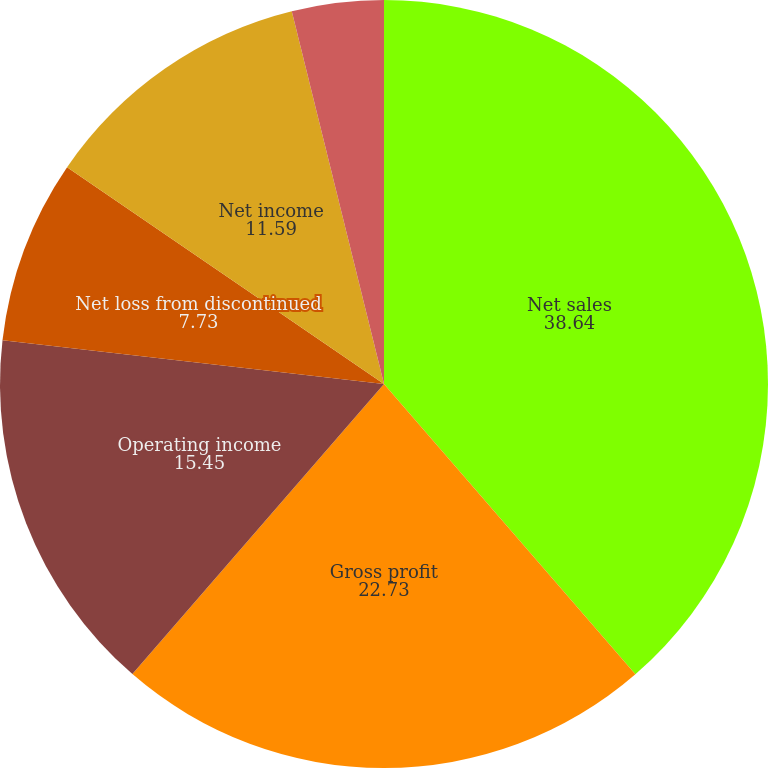<chart> <loc_0><loc_0><loc_500><loc_500><pie_chart><fcel>Net sales<fcel>Gross profit<fcel>Operating income<fcel>Net loss from discontinued<fcel>Net income<fcel>Diluted net loss per common<fcel>Diluted net income per common<nl><fcel>38.64%<fcel>22.73%<fcel>15.45%<fcel>7.73%<fcel>11.59%<fcel>0.0%<fcel>3.86%<nl></chart> 